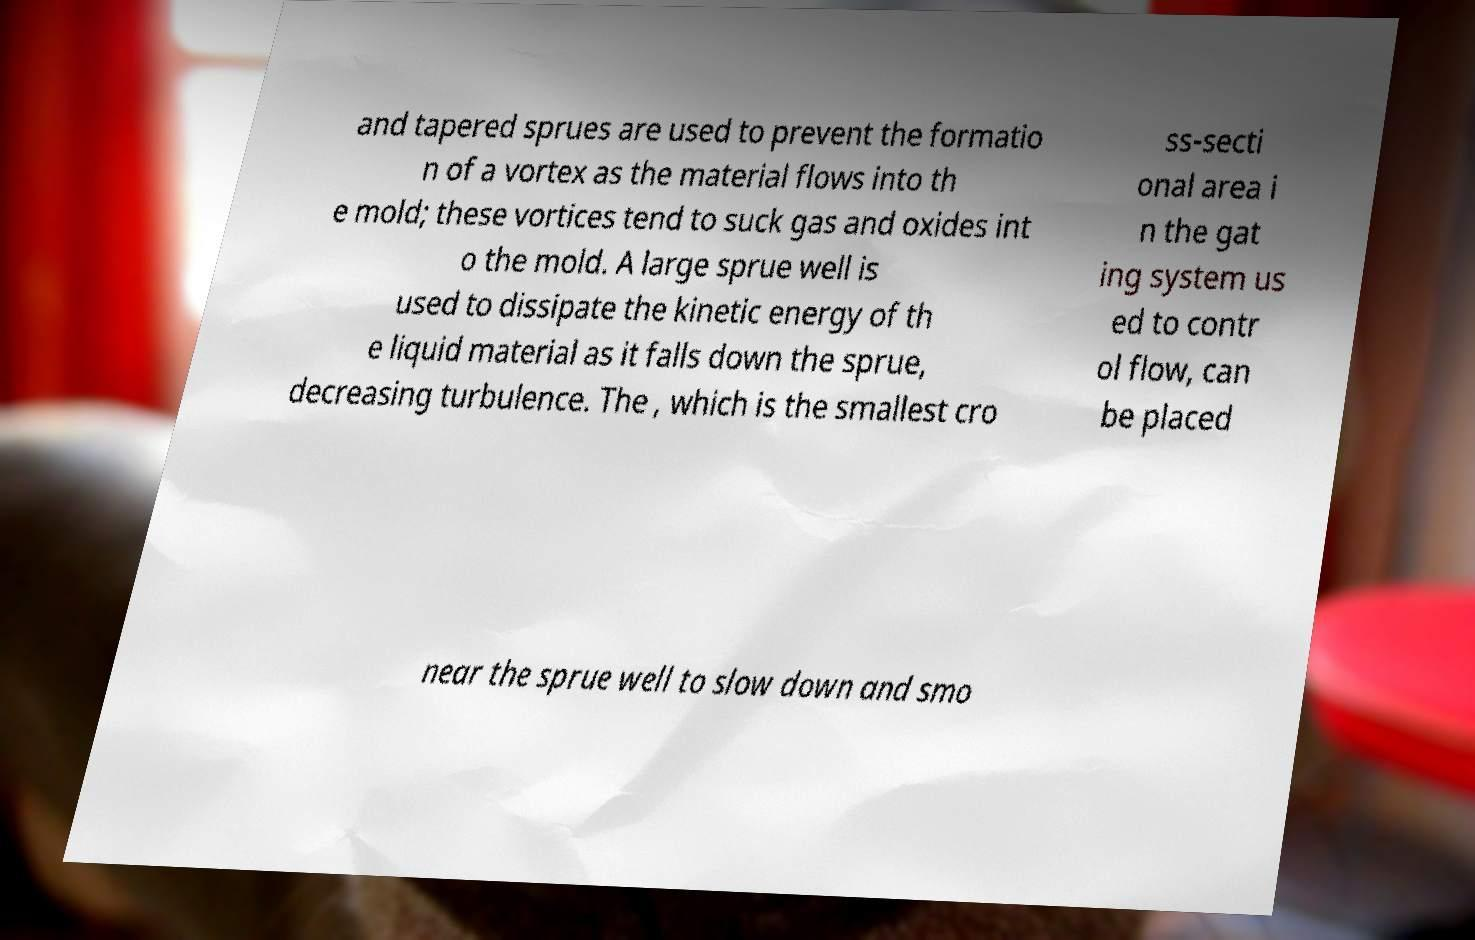Could you extract and type out the text from this image? and tapered sprues are used to prevent the formatio n of a vortex as the material flows into th e mold; these vortices tend to suck gas and oxides int o the mold. A large sprue well is used to dissipate the kinetic energy of th e liquid material as it falls down the sprue, decreasing turbulence. The , which is the smallest cro ss-secti onal area i n the gat ing system us ed to contr ol flow, can be placed near the sprue well to slow down and smo 